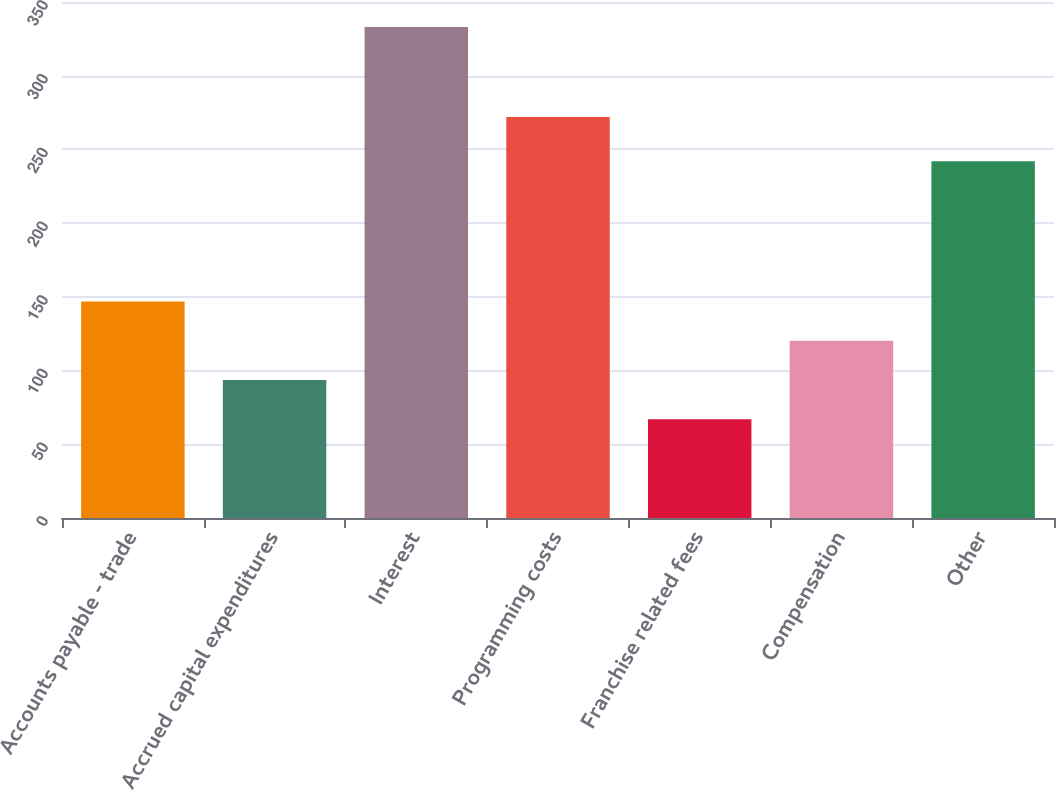<chart> <loc_0><loc_0><loc_500><loc_500><bar_chart><fcel>Accounts payable - trade<fcel>Accrued capital expenditures<fcel>Interest<fcel>Programming costs<fcel>Franchise related fees<fcel>Compensation<fcel>Other<nl><fcel>146.8<fcel>93.6<fcel>333<fcel>272<fcel>67<fcel>120.2<fcel>242<nl></chart> 